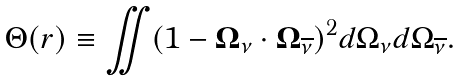Convert formula to latex. <formula><loc_0><loc_0><loc_500><loc_500>\Theta ( r ) \equiv \iint ( 1 - { \boldsymbol \Omega } _ { \nu } \cdot { \boldsymbol \Omega } _ { \overline { \nu } } ) ^ { 2 } d \Omega _ { \nu } d \Omega _ { \overline { \nu } } .</formula> 